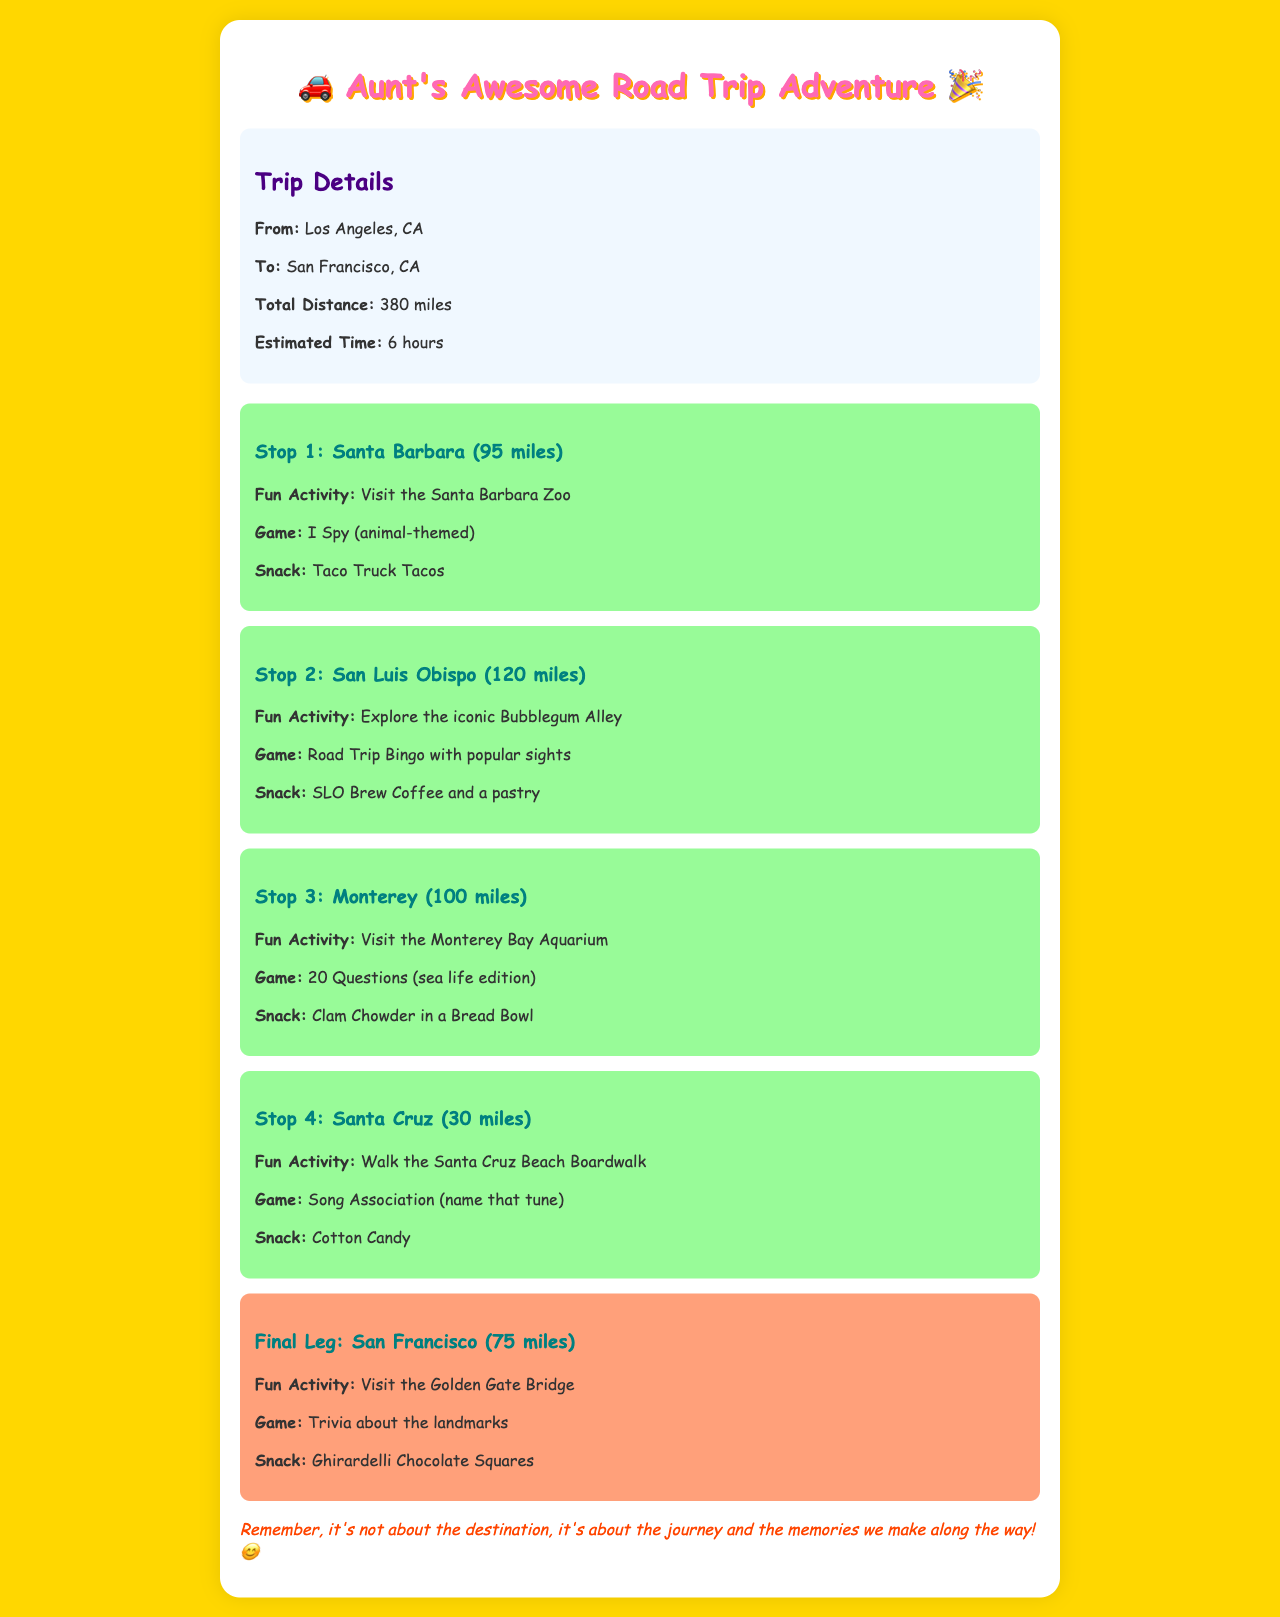What is the starting point of the trip? The starting point is given as Los Angeles, CA in the trip details.
Answer: Los Angeles, CA What is the fun activity at Stop 2? The fun activity listed for Stop 2 is exploring the iconic Bubblegum Alley.
Answer: Explore the iconic Bubblegum Alley How far is Santa Cruz from Monterey? The distance from Monterey to Santa Cruz is mentioned as 30 miles.
Answer: 30 miles What game is suggested for the final leg of the journey? The game for the final leg is trivia about landmarks.
Answer: Trivia about the landmarks What snack is recommended at Santa Barbara? The snack suggested at Santa Barbara is Taco Truck Tacos.
Answer: Taco Truck Tacos What is the total distance of the trip? The total distance of the trip from Los Angeles to San Francisco is 380 miles.
Answer: 380 miles How many stops are there before reaching San Francisco? There are four stops listed before reaching San Francisco.
Answer: Four What is the snack at Santa Cruz? The snack at Santa Cruz is Cotton Candy.
Answer: Cotton Candy 